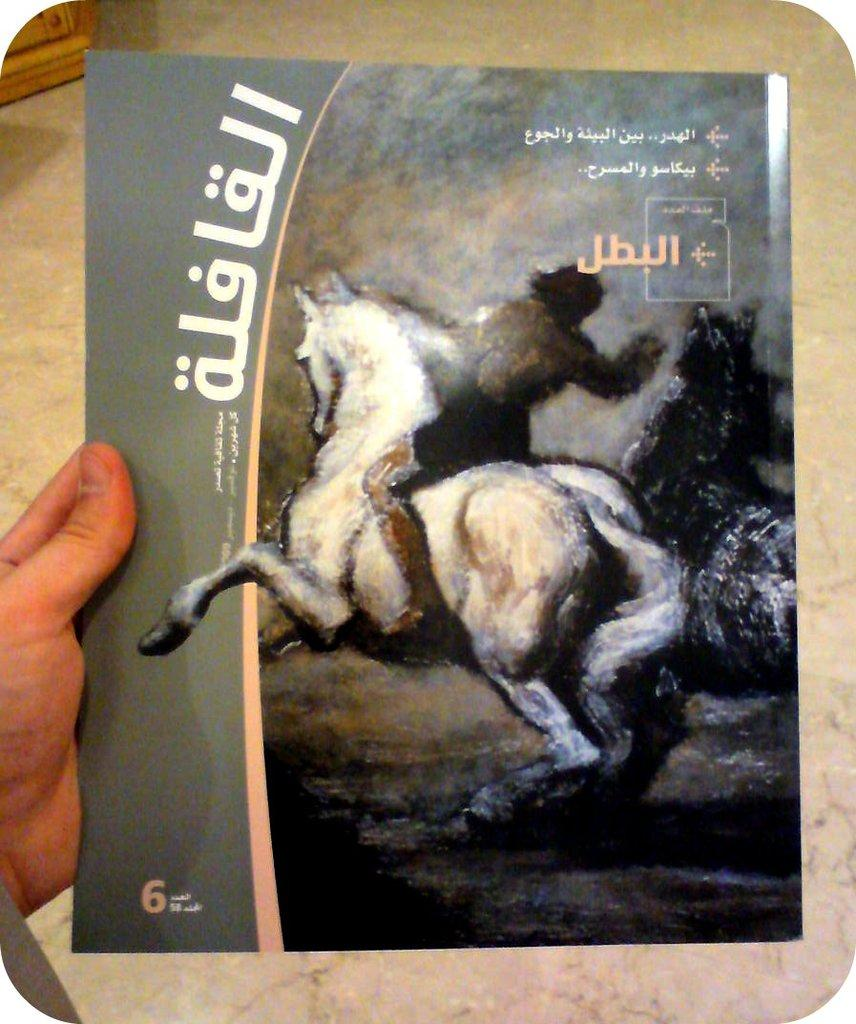<image>
Render a clear and concise summary of the photo. A book with the number 6 on the front has arabic letters on it. 